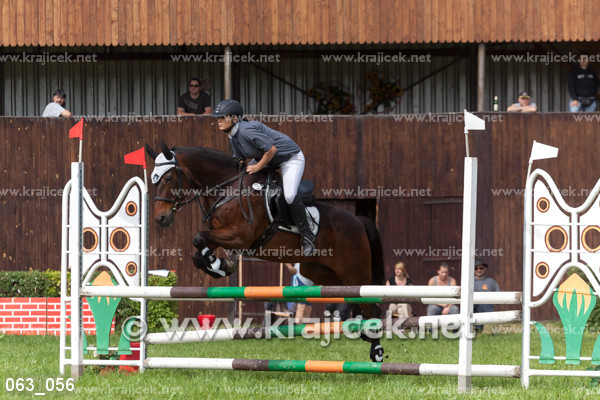Which bar is the horse meant to pass over?
A. top bar
B. right vertical
C. left vertical
D. bottom
Answer with the option's letter from the given choices directly. A 